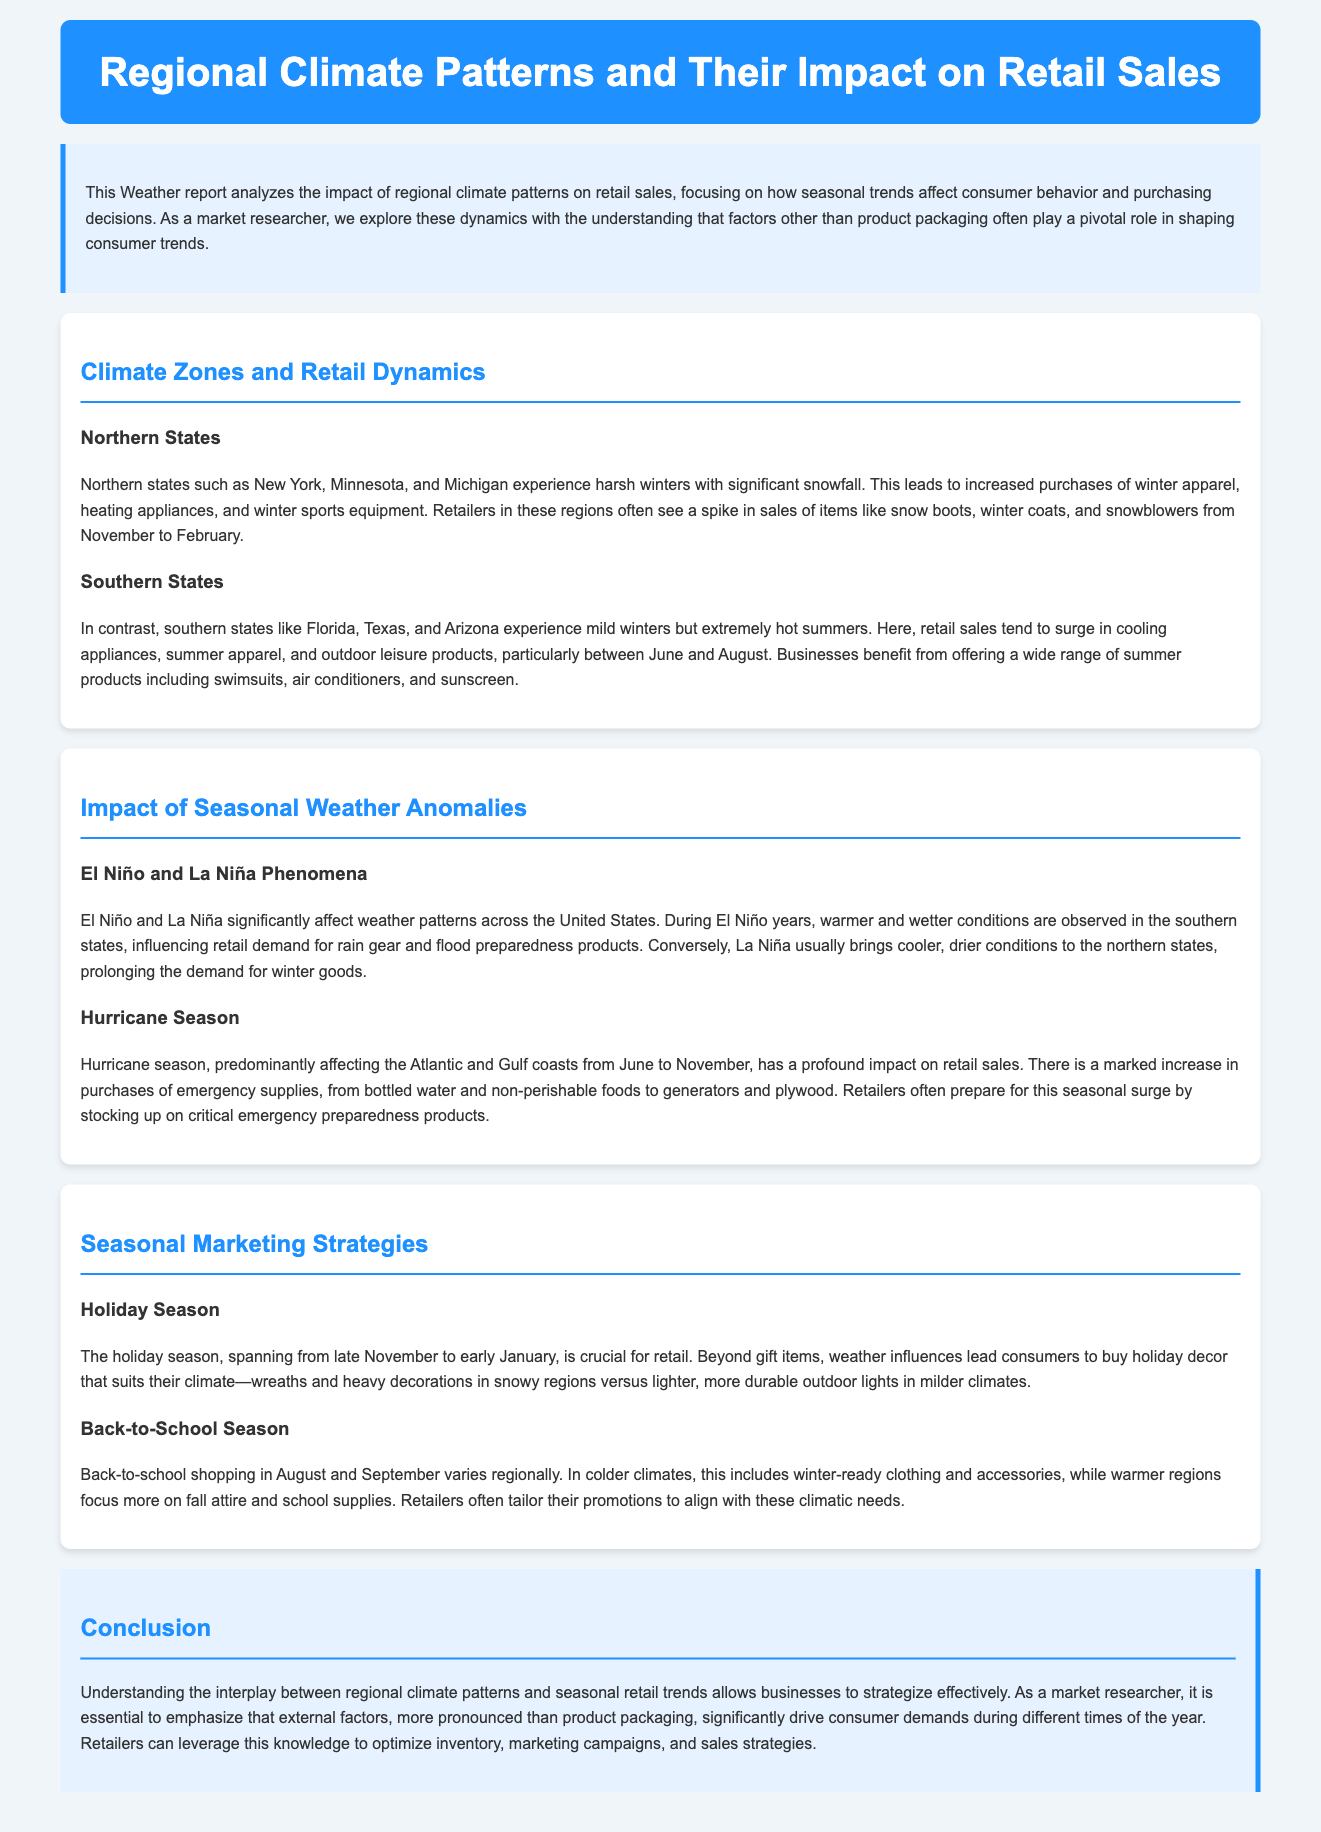What are the northern states mentioned? The document lists New York, Minnesota, and Michigan as northern states, which face harsh winters.
Answer: New York, Minnesota, and Michigan What seasonal trend affects southern states? The document indicates that southern states see increased sales of cooling appliances and summer apparel during extremely hot summers.
Answer: Cooling appliances and summer apparel During which months do northern retailers see a spike in sales? The document states that from November to February, northern states experience increased purchases of winter-related products.
Answer: November to February What phenomenon causes warmer conditions in southern states? The document describes El Niño as a factor that leads to warmer and wetter conditions in the southern states.
Answer: El Niño What type of supplies surge in sales during hurricane season? The document mentions that purchases of emergency supplies, including bottled water and non-perishable foods, increase during hurricane season.
Answer: Emergency supplies What is the impact of La Niña in northern states? The document explains that La Niña usually brings cooler, drier conditions to northern states, affecting winter goods demand.
Answer: Cooler, drier conditions What season is critical for retail according to the report? The document identifies the holiday season from late November to early January as crucial for retail sales.
Answer: Holiday season How do retailers tailor their promotions during back-to-school season? Retailers align promotions with regional climatic needs, focusing on winter-ready clothing in colder climates and fall attire in warmer areas.
Answer: Regional climatic needs What is the purpose of analyzing climate patterns in retail? The document states that understanding climate patterns helps businesses optimize inventory, marketing campaigns, and sales strategies.
Answer: Optimize inventory, marketing, and sales strategies 